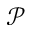Convert formula to latex. <formula><loc_0><loc_0><loc_500><loc_500>\mathcal { P }</formula> 